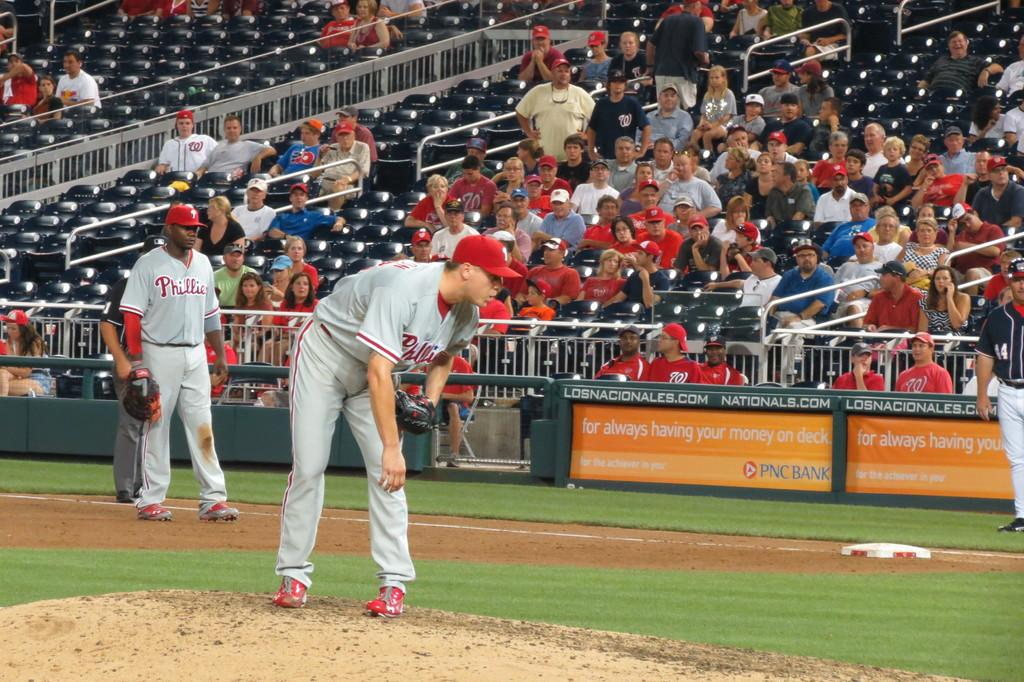Provide a one-sentence caption for the provided image. A group of people watching a player pitch with the word Phillies on his shirt. 